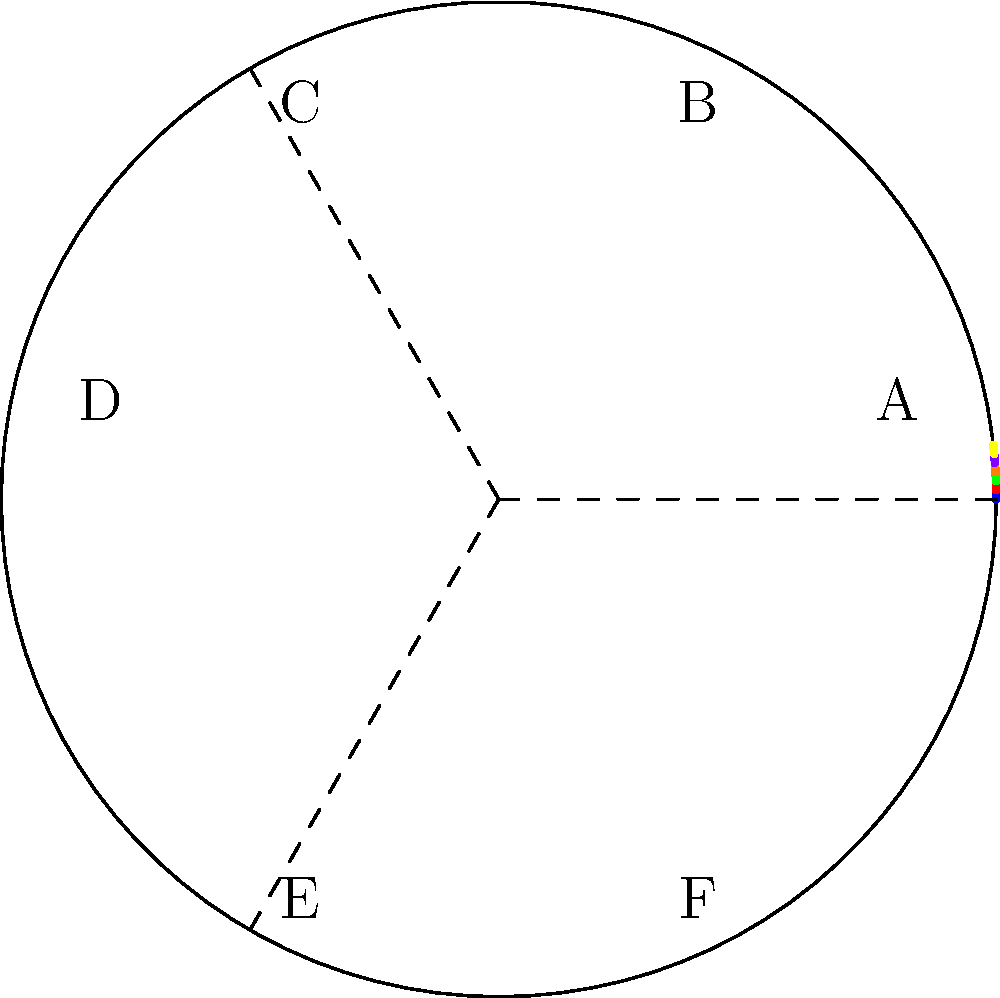You're designing a circular stage for your salsa club's upcoming dance competition. The stage is divided into six equal sections, each represented by a different color and labeled A through F. If section A is represented by the polar equation $r = 5, 0 \leq \theta \leq \frac{\pi}{3}$, what is the polar equation for section D? Let's approach this step-by-step:

1) The stage is circular and divided into six equal sections. This means each section spans an angle of $\frac{2\pi}{6} = \frac{\pi}{3}$ radians.

2) Section A is given by $r = 5, 0 \leq \theta \leq \frac{\pi}{3}$. This tells us that the radius of the stage is 5 units.

3) To find section D, we need to count how many sections it is from A. Going counterclockwise, we see that D is the fourth section.

4) Since each section spans $\frac{\pi}{3}$ radians, the starting angle for section D will be $3 \cdot \frac{\pi}{3} = \pi$ radians from the starting point of A.

5) The ending angle for section D will be $\pi + \frac{\pi}{3} = \frac{4\pi}{3}$ radians.

6) The radius remains constant at 5 units for the entire circle.

Therefore, the polar equation for section D is $r = 5, \pi \leq \theta \leq \frac{4\pi}{3}$.
Answer: $r = 5, \pi \leq \theta \leq \frac{4\pi}{3}$ 